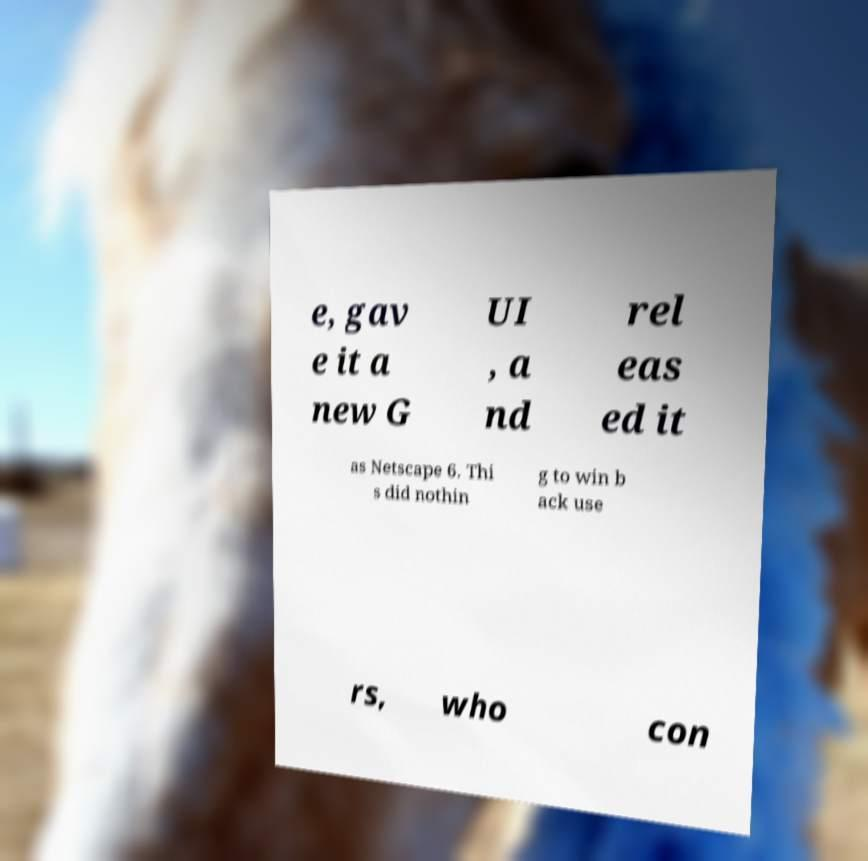For documentation purposes, I need the text within this image transcribed. Could you provide that? e, gav e it a new G UI , a nd rel eas ed it as Netscape 6. Thi s did nothin g to win b ack use rs, who con 